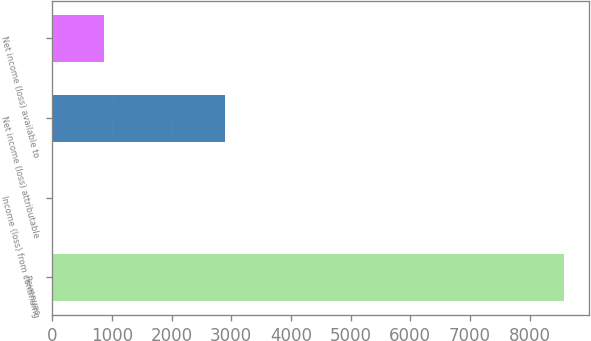Convert chart to OTSL. <chart><loc_0><loc_0><loc_500><loc_500><bar_chart><fcel>Revenues<fcel>Income (loss) from continuing<fcel>Net income (loss) attributable<fcel>Net income (loss) available to<nl><fcel>8570<fcel>3.51<fcel>2888.65<fcel>860.16<nl></chart> 